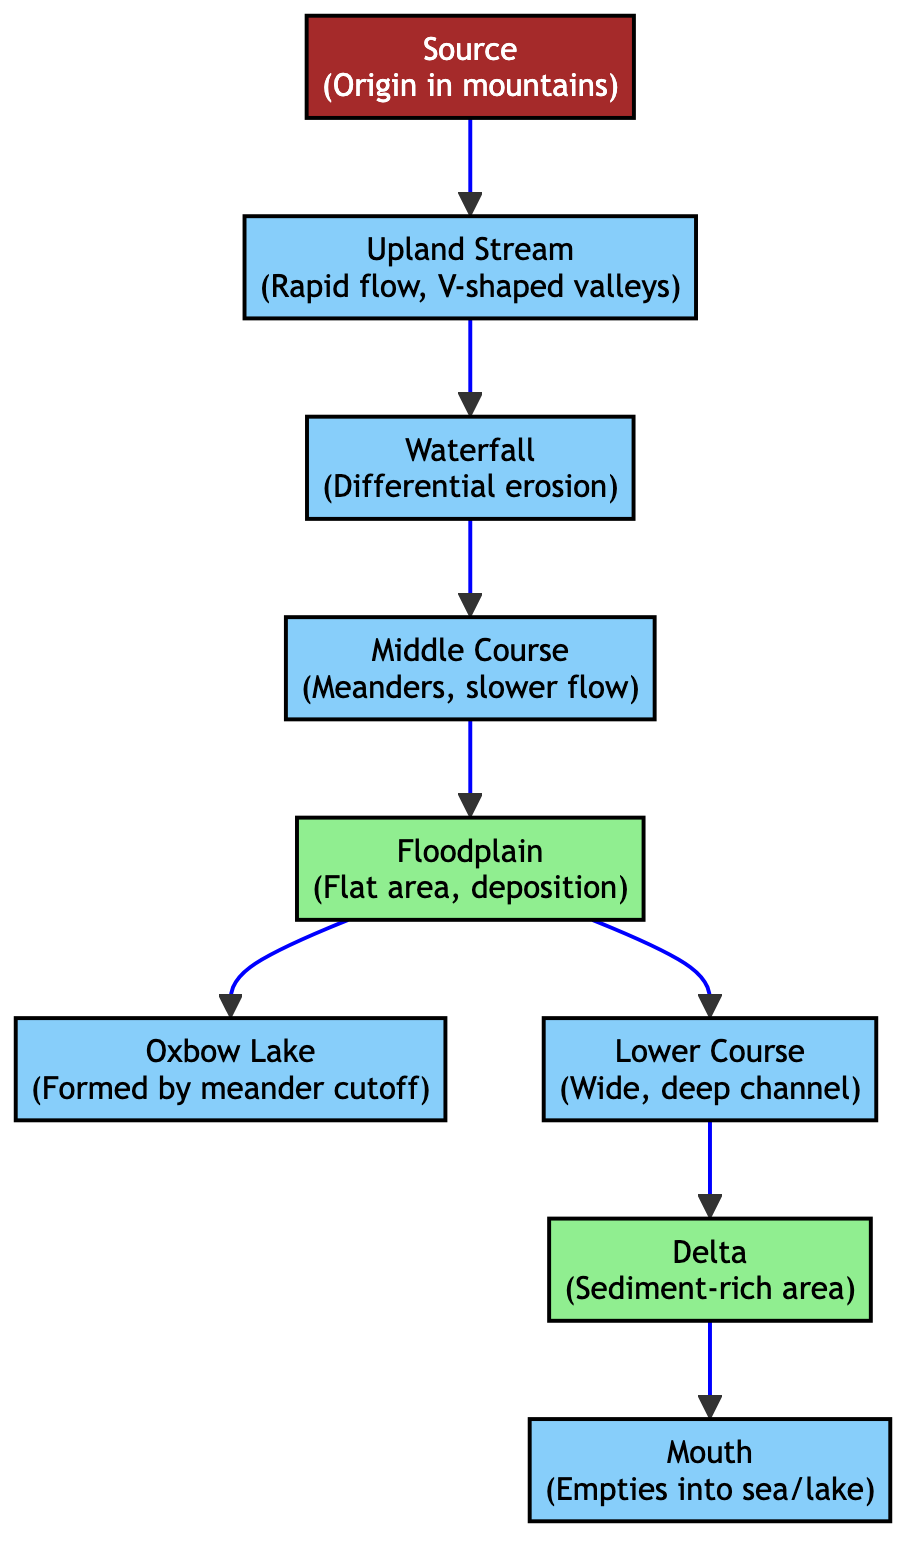What is the first stage of the river's waterway? The first stage of the river's waterway is the "Source," which is indicated at the top of the diagram.
Answer: Source How many courses of the river are shown in the diagram? By counting the distinct stages in the flow from the source to the mouth, there are four courses shown: upland, middle, lower, and floodplain.
Answer: Four What feature is formed by differential erosion? The feature formed by differential erosion is the "Waterfall," as identified in the diagram.
Answer: Waterfall Which area is characterized by slower flow and meanders? The area characterized by slower flow and meanders is the "Middle Course," which can be seen directly in the progression of the river stages.
Answer: Middle Course What is the last feature before the river empties into the sea or lake? The last feature before the river empties into the sea or lake is the "Mouth," which is located at the end of the river's course.
Answer: Mouth What type of landform is produced from meander cutoff? The landform produced from meander cutoff is an "Oxbow Lake," which is directly connected to the floodplain in the diagram.
Answer: Oxbow Lake At which stage does sediment deposition predominantly occur? Sediment deposition predominantly occurs in the "Floodplain," which is indicated as a flat area in the river's progression.
Answer: Floodplain Explain the relationship between the lower course and the delta. The lower course flows directly into the "Delta," which represents the area where sediment is rich and where the river's flow meets the body of water, signifying the end of its journey.
Answer: Flows into What is the significance of the "Delta" in this diagram? The significance of the "Delta" is that it is a sediment-rich area, which is a crucial feature at the end of the river's journey as it deposits materials carried from upstream.
Answer: Sediment-rich area 